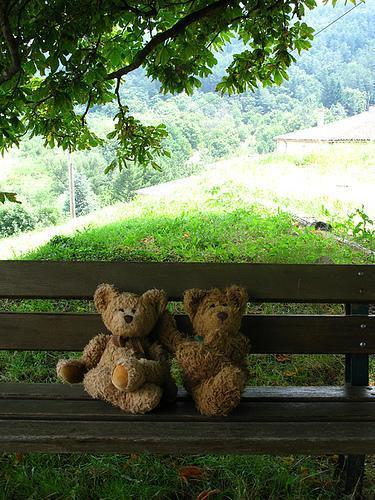How many stuffed animals are on the bench?
Give a very brief answer. 2. How many benches are in the photo?
Give a very brief answer. 1. How many bear arms are raised to the bears' ears?
Give a very brief answer. 1. 